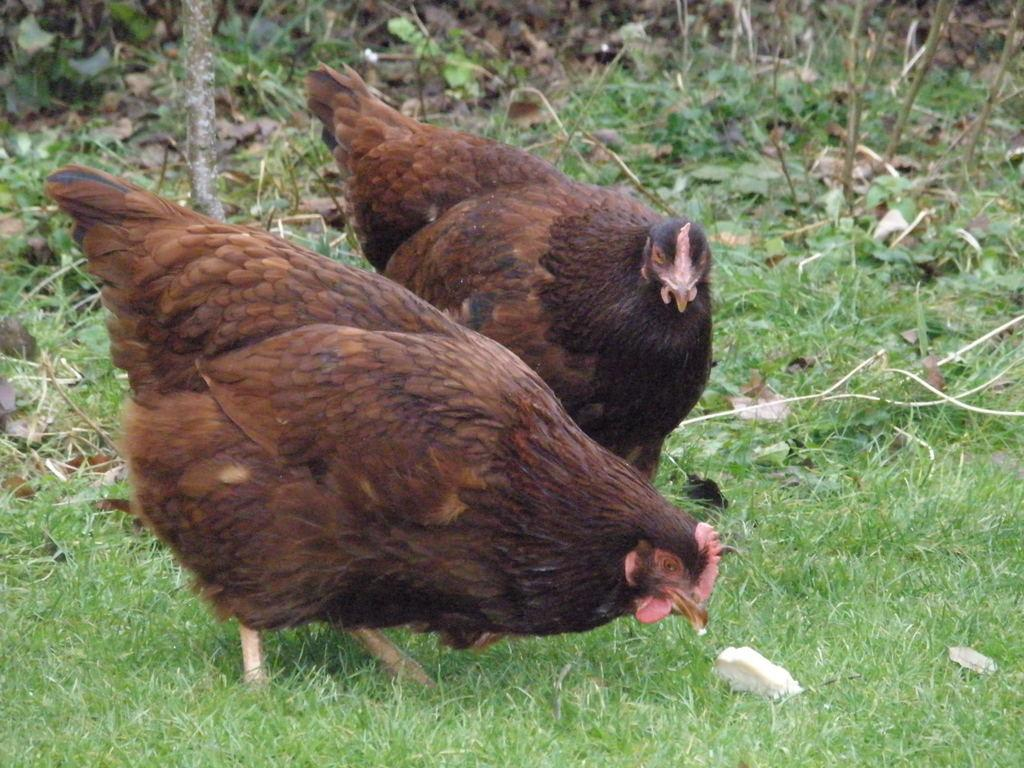What animals are present in the image? There are two hens in the image. Where are the hens located? The hens are on the grass. What type of mist can be seen surrounding the tiger in the image? There is no tiger or mist present in the image; it features two hens on the grass. 